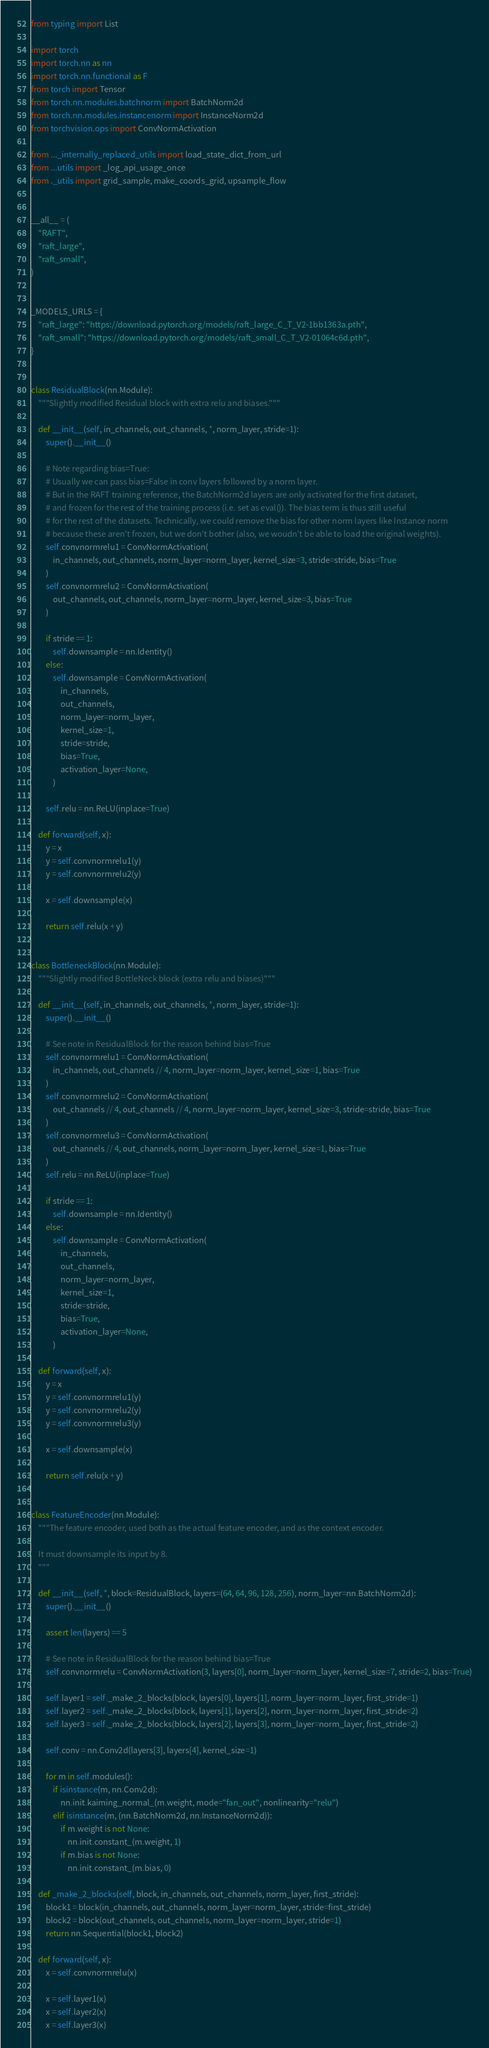Convert code to text. <code><loc_0><loc_0><loc_500><loc_500><_Python_>from typing import List

import torch
import torch.nn as nn
import torch.nn.functional as F
from torch import Tensor
from torch.nn.modules.batchnorm import BatchNorm2d
from torch.nn.modules.instancenorm import InstanceNorm2d
from torchvision.ops import ConvNormActivation

from ..._internally_replaced_utils import load_state_dict_from_url
from ...utils import _log_api_usage_once
from ._utils import grid_sample, make_coords_grid, upsample_flow


__all__ = (
    "RAFT",
    "raft_large",
    "raft_small",
)


_MODELS_URLS = {
    "raft_large": "https://download.pytorch.org/models/raft_large_C_T_V2-1bb1363a.pth",
    "raft_small": "https://download.pytorch.org/models/raft_small_C_T_V2-01064c6d.pth",
}


class ResidualBlock(nn.Module):
    """Slightly modified Residual block with extra relu and biases."""

    def __init__(self, in_channels, out_channels, *, norm_layer, stride=1):
        super().__init__()

        # Note regarding bias=True:
        # Usually we can pass bias=False in conv layers followed by a norm layer.
        # But in the RAFT training reference, the BatchNorm2d layers are only activated for the first dataset,
        # and frozen for the rest of the training process (i.e. set as eval()). The bias term is thus still useful
        # for the rest of the datasets. Technically, we could remove the bias for other norm layers like Instance norm
        # because these aren't frozen, but we don't bother (also, we woudn't be able to load the original weights).
        self.convnormrelu1 = ConvNormActivation(
            in_channels, out_channels, norm_layer=norm_layer, kernel_size=3, stride=stride, bias=True
        )
        self.convnormrelu2 = ConvNormActivation(
            out_channels, out_channels, norm_layer=norm_layer, kernel_size=3, bias=True
        )

        if stride == 1:
            self.downsample = nn.Identity()
        else:
            self.downsample = ConvNormActivation(
                in_channels,
                out_channels,
                norm_layer=norm_layer,
                kernel_size=1,
                stride=stride,
                bias=True,
                activation_layer=None,
            )

        self.relu = nn.ReLU(inplace=True)

    def forward(self, x):
        y = x
        y = self.convnormrelu1(y)
        y = self.convnormrelu2(y)

        x = self.downsample(x)

        return self.relu(x + y)


class BottleneckBlock(nn.Module):
    """Slightly modified BottleNeck block (extra relu and biases)"""

    def __init__(self, in_channels, out_channels, *, norm_layer, stride=1):
        super().__init__()

        # See note in ResidualBlock for the reason behind bias=True
        self.convnormrelu1 = ConvNormActivation(
            in_channels, out_channels // 4, norm_layer=norm_layer, kernel_size=1, bias=True
        )
        self.convnormrelu2 = ConvNormActivation(
            out_channels // 4, out_channels // 4, norm_layer=norm_layer, kernel_size=3, stride=stride, bias=True
        )
        self.convnormrelu3 = ConvNormActivation(
            out_channels // 4, out_channels, norm_layer=norm_layer, kernel_size=1, bias=True
        )
        self.relu = nn.ReLU(inplace=True)

        if stride == 1:
            self.downsample = nn.Identity()
        else:
            self.downsample = ConvNormActivation(
                in_channels,
                out_channels,
                norm_layer=norm_layer,
                kernel_size=1,
                stride=stride,
                bias=True,
                activation_layer=None,
            )

    def forward(self, x):
        y = x
        y = self.convnormrelu1(y)
        y = self.convnormrelu2(y)
        y = self.convnormrelu3(y)

        x = self.downsample(x)

        return self.relu(x + y)


class FeatureEncoder(nn.Module):
    """The feature encoder, used both as the actual feature encoder, and as the context encoder.

    It must downsample its input by 8.
    """

    def __init__(self, *, block=ResidualBlock, layers=(64, 64, 96, 128, 256), norm_layer=nn.BatchNorm2d):
        super().__init__()

        assert len(layers) == 5

        # See note in ResidualBlock for the reason behind bias=True
        self.convnormrelu = ConvNormActivation(3, layers[0], norm_layer=norm_layer, kernel_size=7, stride=2, bias=True)

        self.layer1 = self._make_2_blocks(block, layers[0], layers[1], norm_layer=norm_layer, first_stride=1)
        self.layer2 = self._make_2_blocks(block, layers[1], layers[2], norm_layer=norm_layer, first_stride=2)
        self.layer3 = self._make_2_blocks(block, layers[2], layers[3], norm_layer=norm_layer, first_stride=2)

        self.conv = nn.Conv2d(layers[3], layers[4], kernel_size=1)

        for m in self.modules():
            if isinstance(m, nn.Conv2d):
                nn.init.kaiming_normal_(m.weight, mode="fan_out", nonlinearity="relu")
            elif isinstance(m, (nn.BatchNorm2d, nn.InstanceNorm2d)):
                if m.weight is not None:
                    nn.init.constant_(m.weight, 1)
                if m.bias is not None:
                    nn.init.constant_(m.bias, 0)

    def _make_2_blocks(self, block, in_channels, out_channels, norm_layer, first_stride):
        block1 = block(in_channels, out_channels, norm_layer=norm_layer, stride=first_stride)
        block2 = block(out_channels, out_channels, norm_layer=norm_layer, stride=1)
        return nn.Sequential(block1, block2)

    def forward(self, x):
        x = self.convnormrelu(x)

        x = self.layer1(x)
        x = self.layer2(x)
        x = self.layer3(x)
</code> 